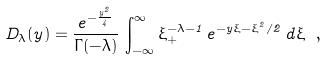<formula> <loc_0><loc_0><loc_500><loc_500>D _ { \lambda } ( y ) = \frac { e ^ { - \frac { y ^ { 2 } } { 4 } } } { \Gamma ( - \lambda ) } \, \int _ { - \infty } ^ { \infty } \xi ^ { - \lambda - 1 } _ { + } \, e ^ { - y \xi - \xi ^ { 2 } / 2 } \, d \xi \ ,</formula> 